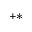<formula> <loc_0><loc_0><loc_500><loc_500>^ { + * }</formula> 